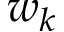Convert formula to latex. <formula><loc_0><loc_0><loc_500><loc_500>w _ { k }</formula> 